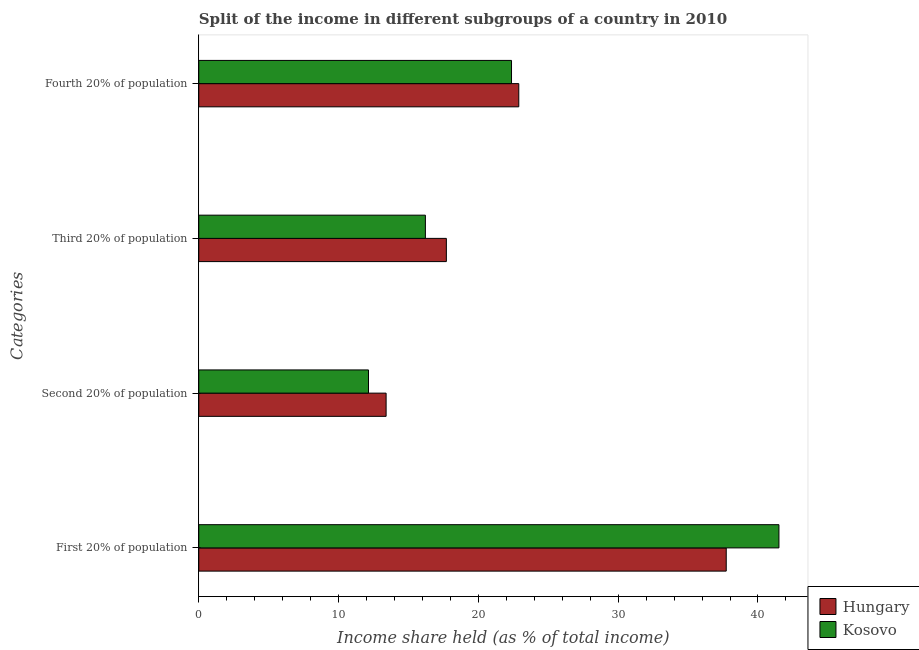How many groups of bars are there?
Offer a terse response. 4. Are the number of bars per tick equal to the number of legend labels?
Give a very brief answer. Yes. How many bars are there on the 4th tick from the bottom?
Your answer should be compact. 2. What is the label of the 1st group of bars from the top?
Ensure brevity in your answer.  Fourth 20% of population. Across all countries, what is the maximum share of the income held by fourth 20% of the population?
Ensure brevity in your answer.  22.89. Across all countries, what is the minimum share of the income held by second 20% of the population?
Your answer should be compact. 12.14. In which country was the share of the income held by third 20% of the population maximum?
Give a very brief answer. Hungary. In which country was the share of the income held by second 20% of the population minimum?
Make the answer very short. Kosovo. What is the total share of the income held by first 20% of the population in the graph?
Make the answer very short. 79.23. What is the difference between the share of the income held by first 20% of the population in Hungary and that in Kosovo?
Your answer should be compact. -3.77. What is the difference between the share of the income held by fourth 20% of the population in Kosovo and the share of the income held by first 20% of the population in Hungary?
Make the answer very short. -15.36. What is the average share of the income held by second 20% of the population per country?
Give a very brief answer. 12.77. What is the difference between the share of the income held by fourth 20% of the population and share of the income held by second 20% of the population in Hungary?
Make the answer very short. 9.49. In how many countries, is the share of the income held by second 20% of the population greater than 10 %?
Offer a very short reply. 2. What is the ratio of the share of the income held by second 20% of the population in Hungary to that in Kosovo?
Provide a succinct answer. 1.1. Is the share of the income held by third 20% of the population in Kosovo less than that in Hungary?
Provide a succinct answer. Yes. What is the difference between the highest and the second highest share of the income held by second 20% of the population?
Your answer should be very brief. 1.26. What is the difference between the highest and the lowest share of the income held by second 20% of the population?
Your answer should be compact. 1.26. In how many countries, is the share of the income held by first 20% of the population greater than the average share of the income held by first 20% of the population taken over all countries?
Keep it short and to the point. 1. Is the sum of the share of the income held by first 20% of the population in Kosovo and Hungary greater than the maximum share of the income held by second 20% of the population across all countries?
Give a very brief answer. Yes. What does the 2nd bar from the top in Third 20% of population represents?
Make the answer very short. Hungary. What does the 2nd bar from the bottom in First 20% of population represents?
Provide a short and direct response. Kosovo. Is it the case that in every country, the sum of the share of the income held by first 20% of the population and share of the income held by second 20% of the population is greater than the share of the income held by third 20% of the population?
Ensure brevity in your answer.  Yes. Does the graph contain any zero values?
Provide a succinct answer. No. Does the graph contain grids?
Make the answer very short. No. What is the title of the graph?
Provide a succinct answer. Split of the income in different subgroups of a country in 2010. What is the label or title of the X-axis?
Offer a very short reply. Income share held (as % of total income). What is the label or title of the Y-axis?
Offer a very short reply. Categories. What is the Income share held (as % of total income) in Hungary in First 20% of population?
Give a very brief answer. 37.73. What is the Income share held (as % of total income) in Kosovo in First 20% of population?
Provide a short and direct response. 41.5. What is the Income share held (as % of total income) of Kosovo in Second 20% of population?
Offer a very short reply. 12.14. What is the Income share held (as % of total income) of Hungary in Third 20% of population?
Offer a terse response. 17.71. What is the Income share held (as % of total income) of Kosovo in Third 20% of population?
Offer a very short reply. 16.21. What is the Income share held (as % of total income) of Hungary in Fourth 20% of population?
Your response must be concise. 22.89. What is the Income share held (as % of total income) of Kosovo in Fourth 20% of population?
Offer a terse response. 22.37. Across all Categories, what is the maximum Income share held (as % of total income) in Hungary?
Ensure brevity in your answer.  37.73. Across all Categories, what is the maximum Income share held (as % of total income) in Kosovo?
Provide a succinct answer. 41.5. Across all Categories, what is the minimum Income share held (as % of total income) in Kosovo?
Your response must be concise. 12.14. What is the total Income share held (as % of total income) of Hungary in the graph?
Keep it short and to the point. 91.73. What is the total Income share held (as % of total income) in Kosovo in the graph?
Keep it short and to the point. 92.22. What is the difference between the Income share held (as % of total income) of Hungary in First 20% of population and that in Second 20% of population?
Your answer should be compact. 24.33. What is the difference between the Income share held (as % of total income) of Kosovo in First 20% of population and that in Second 20% of population?
Make the answer very short. 29.36. What is the difference between the Income share held (as % of total income) of Hungary in First 20% of population and that in Third 20% of population?
Your response must be concise. 20.02. What is the difference between the Income share held (as % of total income) in Kosovo in First 20% of population and that in Third 20% of population?
Give a very brief answer. 25.29. What is the difference between the Income share held (as % of total income) in Hungary in First 20% of population and that in Fourth 20% of population?
Make the answer very short. 14.84. What is the difference between the Income share held (as % of total income) of Kosovo in First 20% of population and that in Fourth 20% of population?
Ensure brevity in your answer.  19.13. What is the difference between the Income share held (as % of total income) in Hungary in Second 20% of population and that in Third 20% of population?
Offer a very short reply. -4.31. What is the difference between the Income share held (as % of total income) in Kosovo in Second 20% of population and that in Third 20% of population?
Provide a short and direct response. -4.07. What is the difference between the Income share held (as % of total income) of Hungary in Second 20% of population and that in Fourth 20% of population?
Offer a terse response. -9.49. What is the difference between the Income share held (as % of total income) of Kosovo in Second 20% of population and that in Fourth 20% of population?
Ensure brevity in your answer.  -10.23. What is the difference between the Income share held (as % of total income) of Hungary in Third 20% of population and that in Fourth 20% of population?
Offer a terse response. -5.18. What is the difference between the Income share held (as % of total income) of Kosovo in Third 20% of population and that in Fourth 20% of population?
Provide a short and direct response. -6.16. What is the difference between the Income share held (as % of total income) in Hungary in First 20% of population and the Income share held (as % of total income) in Kosovo in Second 20% of population?
Offer a very short reply. 25.59. What is the difference between the Income share held (as % of total income) in Hungary in First 20% of population and the Income share held (as % of total income) in Kosovo in Third 20% of population?
Give a very brief answer. 21.52. What is the difference between the Income share held (as % of total income) of Hungary in First 20% of population and the Income share held (as % of total income) of Kosovo in Fourth 20% of population?
Provide a succinct answer. 15.36. What is the difference between the Income share held (as % of total income) in Hungary in Second 20% of population and the Income share held (as % of total income) in Kosovo in Third 20% of population?
Keep it short and to the point. -2.81. What is the difference between the Income share held (as % of total income) of Hungary in Second 20% of population and the Income share held (as % of total income) of Kosovo in Fourth 20% of population?
Ensure brevity in your answer.  -8.97. What is the difference between the Income share held (as % of total income) in Hungary in Third 20% of population and the Income share held (as % of total income) in Kosovo in Fourth 20% of population?
Provide a short and direct response. -4.66. What is the average Income share held (as % of total income) in Hungary per Categories?
Offer a very short reply. 22.93. What is the average Income share held (as % of total income) of Kosovo per Categories?
Give a very brief answer. 23.05. What is the difference between the Income share held (as % of total income) of Hungary and Income share held (as % of total income) of Kosovo in First 20% of population?
Ensure brevity in your answer.  -3.77. What is the difference between the Income share held (as % of total income) of Hungary and Income share held (as % of total income) of Kosovo in Second 20% of population?
Make the answer very short. 1.26. What is the difference between the Income share held (as % of total income) in Hungary and Income share held (as % of total income) in Kosovo in Third 20% of population?
Offer a very short reply. 1.5. What is the difference between the Income share held (as % of total income) in Hungary and Income share held (as % of total income) in Kosovo in Fourth 20% of population?
Your answer should be compact. 0.52. What is the ratio of the Income share held (as % of total income) in Hungary in First 20% of population to that in Second 20% of population?
Your response must be concise. 2.82. What is the ratio of the Income share held (as % of total income) in Kosovo in First 20% of population to that in Second 20% of population?
Offer a terse response. 3.42. What is the ratio of the Income share held (as % of total income) in Hungary in First 20% of population to that in Third 20% of population?
Your answer should be compact. 2.13. What is the ratio of the Income share held (as % of total income) in Kosovo in First 20% of population to that in Third 20% of population?
Make the answer very short. 2.56. What is the ratio of the Income share held (as % of total income) of Hungary in First 20% of population to that in Fourth 20% of population?
Offer a terse response. 1.65. What is the ratio of the Income share held (as % of total income) of Kosovo in First 20% of population to that in Fourth 20% of population?
Make the answer very short. 1.86. What is the ratio of the Income share held (as % of total income) in Hungary in Second 20% of population to that in Third 20% of population?
Your answer should be very brief. 0.76. What is the ratio of the Income share held (as % of total income) of Kosovo in Second 20% of population to that in Third 20% of population?
Provide a succinct answer. 0.75. What is the ratio of the Income share held (as % of total income) of Hungary in Second 20% of population to that in Fourth 20% of population?
Provide a short and direct response. 0.59. What is the ratio of the Income share held (as % of total income) in Kosovo in Second 20% of population to that in Fourth 20% of population?
Offer a very short reply. 0.54. What is the ratio of the Income share held (as % of total income) of Hungary in Third 20% of population to that in Fourth 20% of population?
Give a very brief answer. 0.77. What is the ratio of the Income share held (as % of total income) of Kosovo in Third 20% of population to that in Fourth 20% of population?
Provide a short and direct response. 0.72. What is the difference between the highest and the second highest Income share held (as % of total income) in Hungary?
Your answer should be very brief. 14.84. What is the difference between the highest and the second highest Income share held (as % of total income) of Kosovo?
Give a very brief answer. 19.13. What is the difference between the highest and the lowest Income share held (as % of total income) in Hungary?
Provide a short and direct response. 24.33. What is the difference between the highest and the lowest Income share held (as % of total income) in Kosovo?
Your answer should be compact. 29.36. 